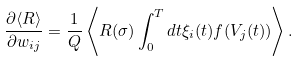<formula> <loc_0><loc_0><loc_500><loc_500>\frac { \partial \langle R \rangle } { \partial w _ { i j } } = \frac { 1 } { Q } \left \langle R ( \sigma ) \int _ { 0 } ^ { T } d t \xi _ { i } ( t ) f ( V _ { j } ( t ) ) \right \rangle .</formula> 